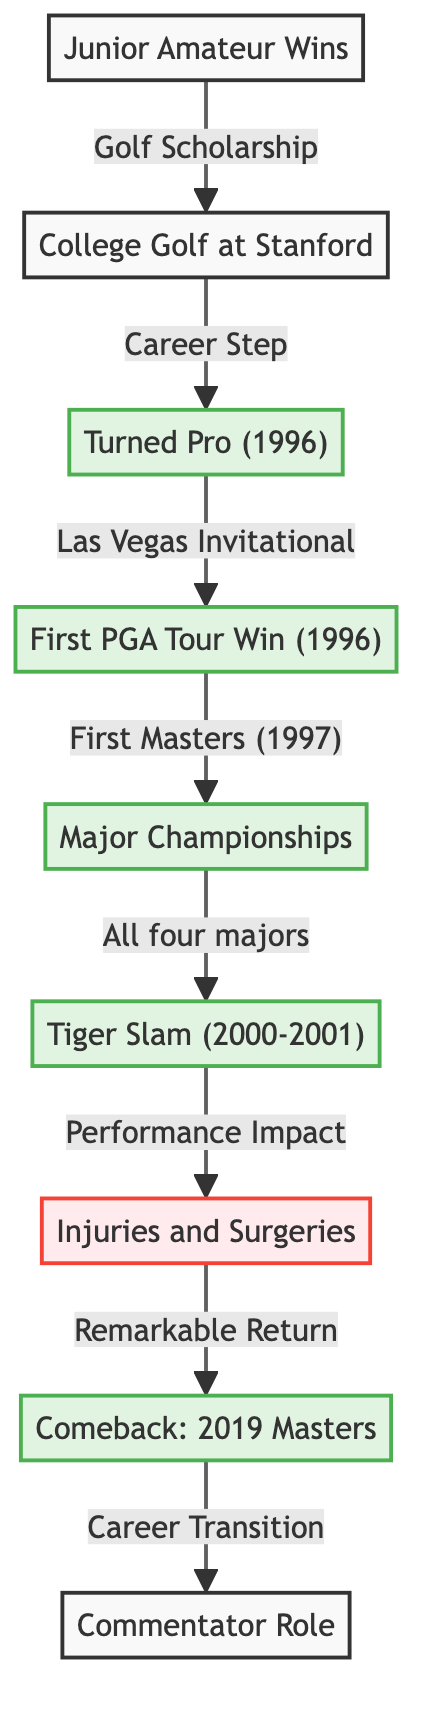What was the year the golfer turned pro? The diagram indicates the milestone of "Turned Pro" and directly states the year as 1996. Therefore, by identifying this milestone, we can conclusively say the year.
Answer: 1996 What was the first PGA Tour win? The diagram specifies the milestone of "First PGA Tour Win" as occurring in the same year of turning pro, 1996, and elaborates on it with the node directly named "Las Vegas Invitational." So, we can identify this specific win.
Answer: Las Vegas Invitational What are the major championships indicated in the diagram? By examining the "Major Championships" node in the diagram, it is clear that it represents a collective grouping of wins, linking to the specific milestone of "All four majors" described earlier in the diagram.
Answer: All four majors Which event led to the injuries noted in the diagram? The flow from "Tiger Slam" leads to "Injuries and Surgeries," indicating that this period of excellence was followed by setbacks. Hence, we deduce that the injuries were an outcome of performance post-Tiger Slam.
Answer: Tiger Slam What milestone follows the comeback in the career timeline? After the milestone of "Comeback: 2019 Masters," we see a direct link to "Commentator Role," signifying the transition in the golfer's career following the comeback milestone.
Answer: Commentator Role What is the nature of the injuries listed in the diagram? The node labeled "Injuries and Surgeries" is classified with a distinctive style reflecting a setback, indicating that the nature of these injuries was significant enough to impact the golfer's career.
Answer: Setback How many significant career milestones are represented in the diagram? The diagram outlines several milestones specifically indicated by the bold node styles, which include "Turned Pro," "First PGA Tour Win," "Major Championships," "Tiger Slam," and "Comeback: 2019 Masters." Counting these gives us the total number of significant milestones.
Answer: Five What does the arrow from "First PGA Tour Win" lead to? The arrow from "First PGA Tour Win" connects directly to "Major Championships" in the progression of the golfer's career, indicating a clear pathway between early success and later major wins. This shows how one achievement leads into the next significant phase.
Answer: Major Championships What signifies the end of the competitive playing career in the diagram? The transition represented from "Comeback: 2019 Masters" to "Commentator Role" illustrates where the competitive playing career effectively ends, as it leads to a new role in commentary.
Answer: Commentator Role 